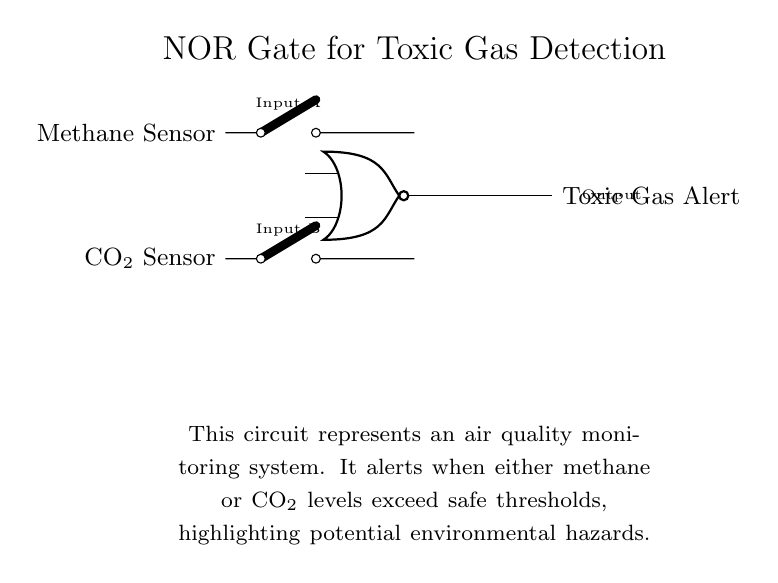What are the inputs of the NOR gate? The inputs of the NOR gate are the Methane Sensor and the CO2 Sensor, which are represented in the diagram as switches leading to the gate.
Answer: Methane Sensor, CO2 Sensor What does the output indicate when the gate is triggered? The output "Toxic Gas Alert" indicates that either the methane or CO2 levels have exceeded safe thresholds, warning of potential environmental hazards.
Answer: Toxic Gas Alert How many sensors are used in this circuit? There are two sensors in this circuit: one for methane and one for CO2, each connected to the inputs of the NOR gate.
Answer: Two sensors What type of logic gate is used in this circuit? The circuit employs a NOR gate, which gives a low output when any of its inputs are high. It is specifically designed to detect low levels of both gases and alert when pollution levels are high.
Answer: NOR gate What does the environmental context note imply about the circuit’s purpose? The environmental context specifies that this circuit is part of an air quality monitoring system aimed at detecting hazardous gas levels, thereby emphasizing its role in safety and awareness of environmental conditions.
Answer: Air quality monitoring system When will the output be activated? The output will be activated (indicating a toxic gas alert) when both the Methane Sensor and CO2 Sensor detect levels below the safe threshold, as the NOR gate only sends an alert when both inputs are low.
Answer: When both inputs are low What type of output does the circuit deliver? The output of this circuit is a simple alert signal indicating the presence of toxic gases, which serves a critical role in environmental safety monitoring.
Answer: Alert signal 